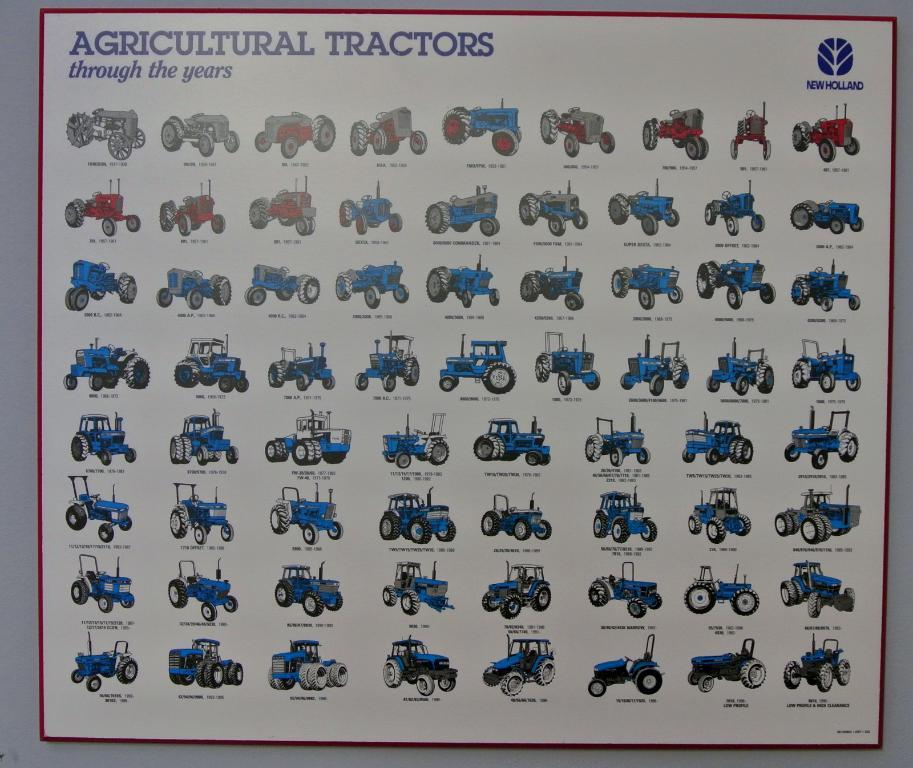What is present on the wall in the image? There is a board attached to the wall in the image. What is written on the board? The board has text written on it, which says "agricultural tractor." Are there any visual elements on the board besides the text? Yes, there are pictures on the board. Is there a fan visible in the image that is expressing regret for not being able to cool the room? No, there is no fan present in the image, and the concept of regret is not applicable to inanimate objects like fans. 